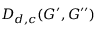Convert formula to latex. <formula><loc_0><loc_0><loc_500><loc_500>D _ { d , c } ( G ^ { \prime } , G ^ { \prime \prime } )</formula> 